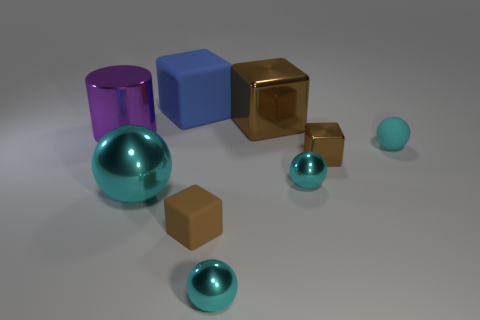How many things are either rubber blocks that are behind the purple cylinder or brown things that are in front of the large metal cube?
Make the answer very short. 3. What is the size of the brown shiny block in front of the matte object that is to the right of the large brown block?
Offer a very short reply. Small. There is a metallic sphere that is behind the big cyan metallic ball; is its color the same as the tiny rubber sphere?
Keep it short and to the point. Yes. Is there a purple metal thing that has the same shape as the cyan rubber thing?
Provide a succinct answer. No. There is a shiny block that is the same size as the cyan matte sphere; what is its color?
Provide a succinct answer. Brown. There is a shiny ball that is on the left side of the big blue rubber cube; how big is it?
Provide a succinct answer. Large. There is a large rubber thing behind the large sphere; are there any tiny brown matte cubes that are left of it?
Give a very brief answer. No. Do the brown thing behind the cyan rubber thing and the blue cube have the same material?
Your answer should be very brief. No. What number of metal objects are on the right side of the large blue thing and in front of the big purple metallic object?
Make the answer very short. 3. How many spheres have the same material as the blue cube?
Make the answer very short. 1. 